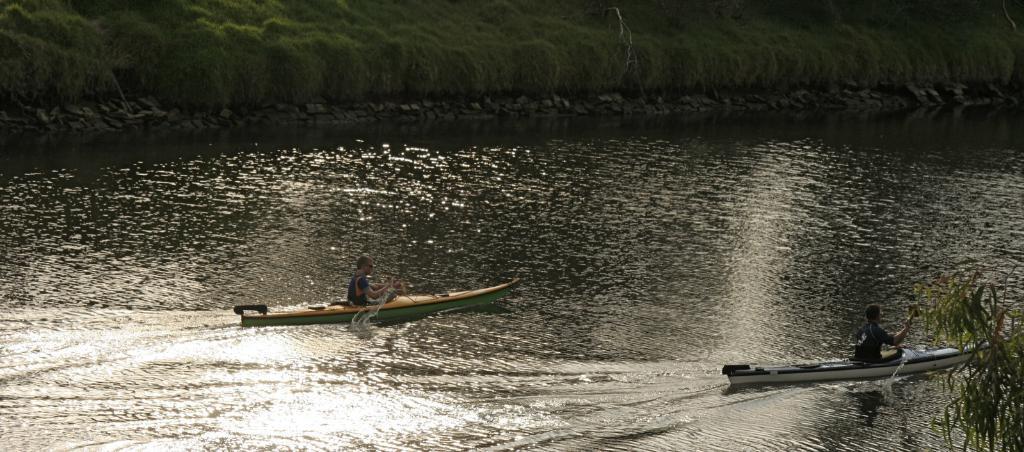In one or two sentences, can you explain what this image depicts? As we can see in the image there are two people sitting on boats and there is water. In the background there are trees. 